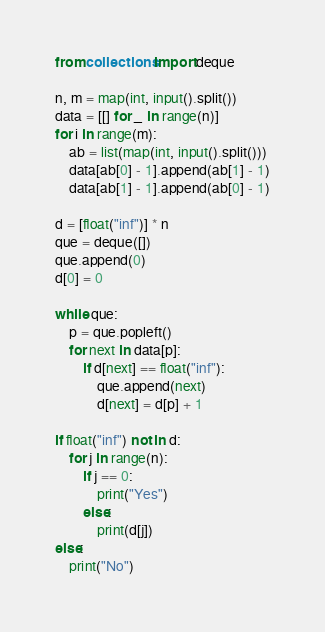Convert code to text. <code><loc_0><loc_0><loc_500><loc_500><_Python_>from collections import deque

n, m = map(int, input().split())
data = [[] for _ in range(n)]
for i in range(m):
    ab = list(map(int, input().split()))
    data[ab[0] - 1].append(ab[1] - 1)
    data[ab[1] - 1].append(ab[0] - 1)

d = [float("inf")] * n
que = deque([])
que.append(0)
d[0] = 0

while que:
    p = que.popleft()
    for next in data[p]:
        if d[next] == float("inf"):
            que.append(next)
            d[next] = d[p] + 1

if float("inf") not in d:
    for j in range(n):
        if j == 0:
            print("Yes")
        else:
            print(d[j])
else:
    print("No")
</code> 